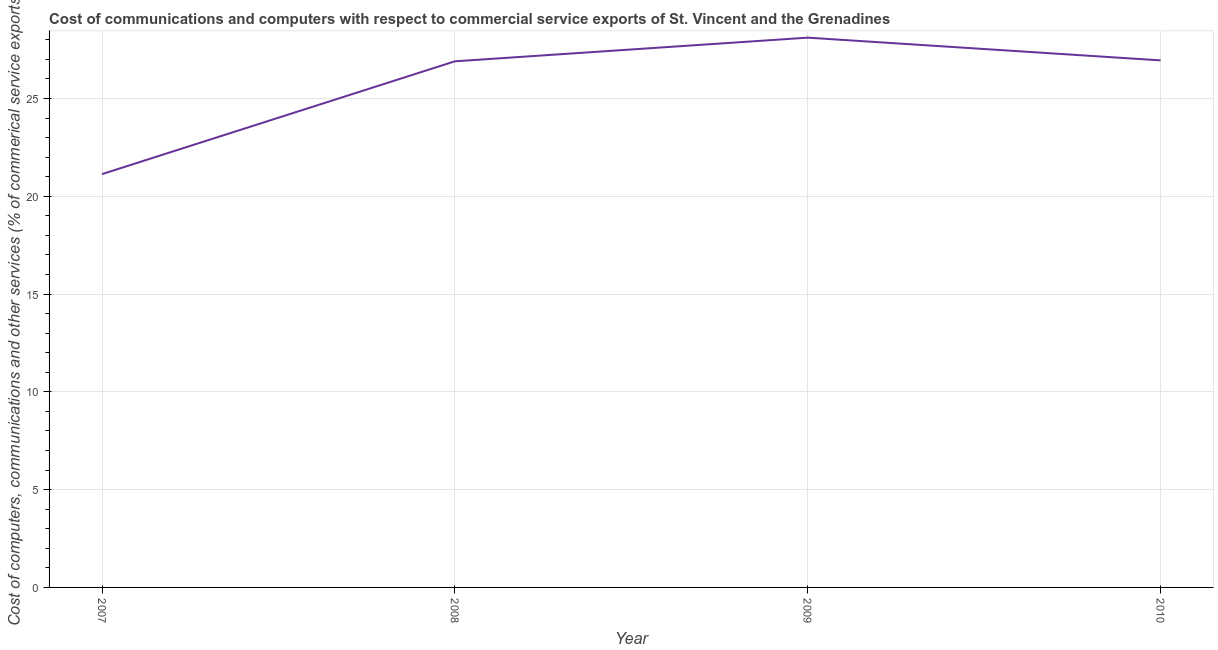What is the cost of communications in 2009?
Provide a short and direct response. 28.11. Across all years, what is the maximum  computer and other services?
Make the answer very short. 28.11. Across all years, what is the minimum cost of communications?
Give a very brief answer. 21.13. What is the sum of the  computer and other services?
Ensure brevity in your answer.  103.09. What is the difference between the cost of communications in 2007 and 2008?
Give a very brief answer. -5.77. What is the average  computer and other services per year?
Provide a succinct answer. 25.77. What is the median  computer and other services?
Your answer should be compact. 26.92. What is the ratio of the  computer and other services in 2008 to that in 2009?
Make the answer very short. 0.96. Is the cost of communications in 2009 less than that in 2010?
Ensure brevity in your answer.  No. What is the difference between the highest and the second highest cost of communications?
Give a very brief answer. 1.16. Is the sum of the  computer and other services in 2007 and 2008 greater than the maximum  computer and other services across all years?
Offer a very short reply. Yes. What is the difference between the highest and the lowest cost of communications?
Your response must be concise. 6.98. Does the cost of communications monotonically increase over the years?
Offer a very short reply. No. How many lines are there?
Your response must be concise. 1. What is the difference between two consecutive major ticks on the Y-axis?
Your answer should be compact. 5. Are the values on the major ticks of Y-axis written in scientific E-notation?
Keep it short and to the point. No. What is the title of the graph?
Offer a terse response. Cost of communications and computers with respect to commercial service exports of St. Vincent and the Grenadines. What is the label or title of the Y-axis?
Offer a very short reply. Cost of computers, communications and other services (% of commerical service exports). What is the Cost of computers, communications and other services (% of commerical service exports) in 2007?
Give a very brief answer. 21.13. What is the Cost of computers, communications and other services (% of commerical service exports) of 2008?
Your answer should be very brief. 26.9. What is the Cost of computers, communications and other services (% of commerical service exports) in 2009?
Your answer should be compact. 28.11. What is the Cost of computers, communications and other services (% of commerical service exports) in 2010?
Your response must be concise. 26.95. What is the difference between the Cost of computers, communications and other services (% of commerical service exports) in 2007 and 2008?
Offer a terse response. -5.77. What is the difference between the Cost of computers, communications and other services (% of commerical service exports) in 2007 and 2009?
Your answer should be very brief. -6.98. What is the difference between the Cost of computers, communications and other services (% of commerical service exports) in 2007 and 2010?
Provide a short and direct response. -5.81. What is the difference between the Cost of computers, communications and other services (% of commerical service exports) in 2008 and 2009?
Your response must be concise. -1.21. What is the difference between the Cost of computers, communications and other services (% of commerical service exports) in 2008 and 2010?
Offer a terse response. -0.05. What is the difference between the Cost of computers, communications and other services (% of commerical service exports) in 2009 and 2010?
Your answer should be compact. 1.16. What is the ratio of the Cost of computers, communications and other services (% of commerical service exports) in 2007 to that in 2008?
Your response must be concise. 0.79. What is the ratio of the Cost of computers, communications and other services (% of commerical service exports) in 2007 to that in 2009?
Ensure brevity in your answer.  0.75. What is the ratio of the Cost of computers, communications and other services (% of commerical service exports) in 2007 to that in 2010?
Your answer should be compact. 0.78. What is the ratio of the Cost of computers, communications and other services (% of commerical service exports) in 2009 to that in 2010?
Provide a short and direct response. 1.04. 